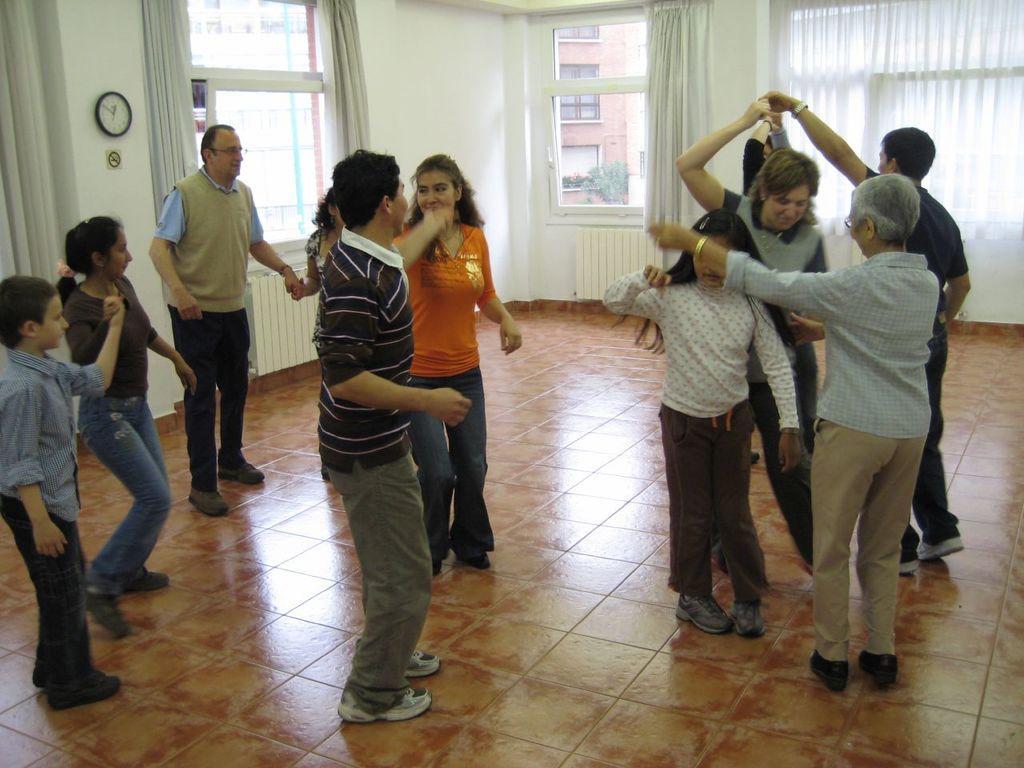Please provide a concise description of this image. In this picture we can see some people are dancing. In the background of the image we can see the curtains, windows, clock and board are present on the wall. Through the windows we can see the buildings, windows, tree. At the bottom of the image we can see the floor. 